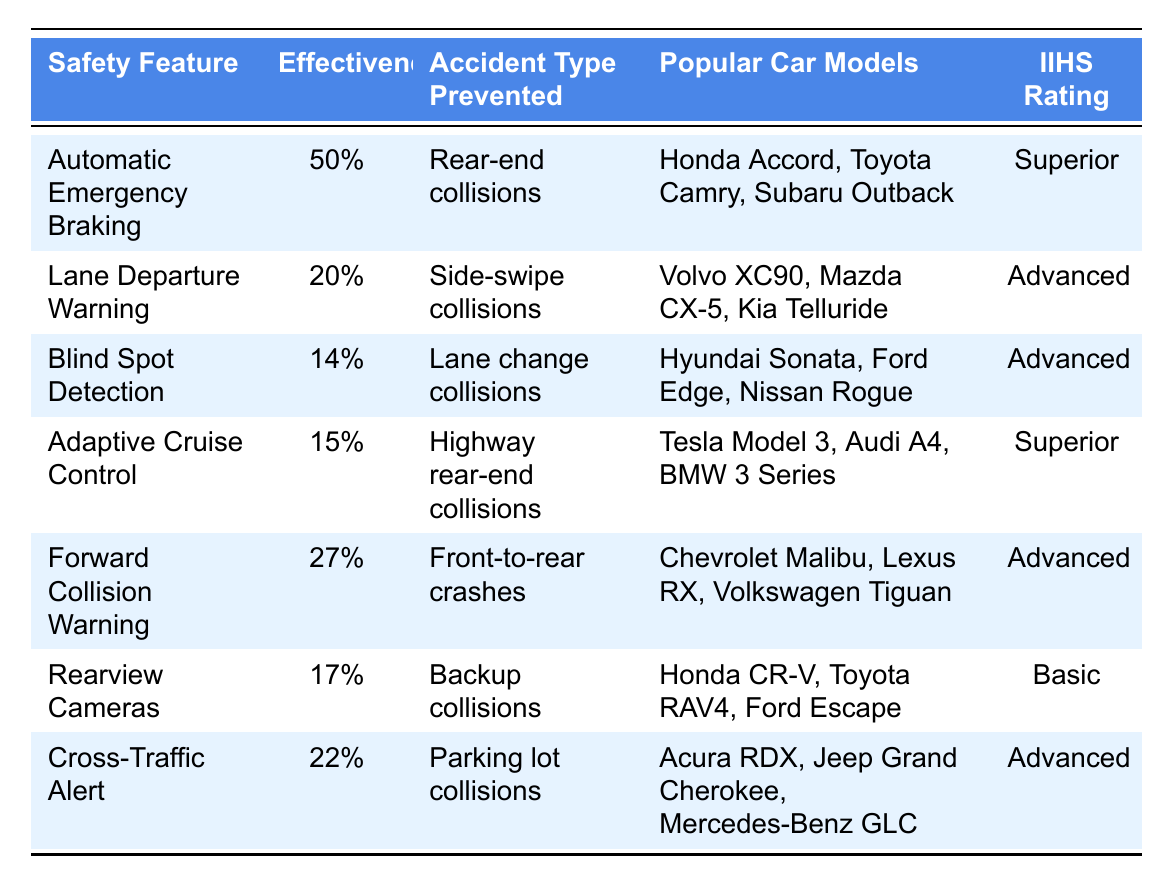What is the effectiveness percentage of Automatic Emergency Braking? The table shows the effectiveness percentage of Automatic Emergency Braking, which is listed next to the feature name. It states 50%.
Answer: 50% Which safety feature has the lowest effectiveness percentage? By reviewing the effectiveness percentages listed for each safety feature, Blind Spot Detection has the lowest effectiveness percentage at 14%.
Answer: Blind Spot Detection How many popular car models are associated with Cross-Traffic Alert? The table lists three popular car models for the Cross-Traffic Alert feature: Acura RDX, Jeep Grand Cherokee, and Mercedes-Benz GLC. Therefore, the total is three models.
Answer: 3 What accident type is prevented by Adaptive Cruise Control? The table indicates that Adaptive Cruise Control prevents highway rear-end collisions.
Answer: Highway rear-end collisions Is the IIHS rating for Rearview Cameras better than Advanced? The table shows that the IIHS rating for Rearview Cameras is Basic, while Advanced is a higher rating. Therefore, it is not better.
Answer: No What is the average effectiveness percentage of all the listed safety features? First, sum the effectiveness percentages: 50 + 20 + 14 + 15 + 27 + 17 + 22 = 165. Then, divide by the number of features (7) to get an average of 165/7 ≈ 23.57.
Answer: Approximately 23.57% Which safety feature is rated Superior and prevents rear-end collisions? The table states that Automatic Emergency Braking is rated Superior and it prevents rear-end collisions.
Answer: Automatic Emergency Braking What are the popular car models for Blind Spot Detection? The table lists the popular car models for Blind Spot Detection as Hyundai Sonata, Ford Edge, and Nissan Rogue.
Answer: Hyundai Sonata, Ford Edge, Nissan Rogue Which safety feature has a higher effectiveness, Lane Departure Warning or Cross-Traffic Alert? The effectiveness of Lane Departure Warning is 20%, and Cross-Traffic Alert is 22%. Since 22% is higher, Cross-Traffic Alert has a higher effectiveness.
Answer: Cross-Traffic Alert Is there any safety feature that prevents both backup collisions and has an IIHS rating of Superior? Rearview Cameras prevent backup collisions but have an IIHS rating of Basic, and no other feature prevents backup collisions. Therefore, the answer is no.
Answer: No What is the IIHS rating for the feature that prevents front-to-rear crashes? The table states that the feature Forward Collision Warning prevents front-to-rear crashes and its IIHS rating is Advanced.
Answer: Advanced 